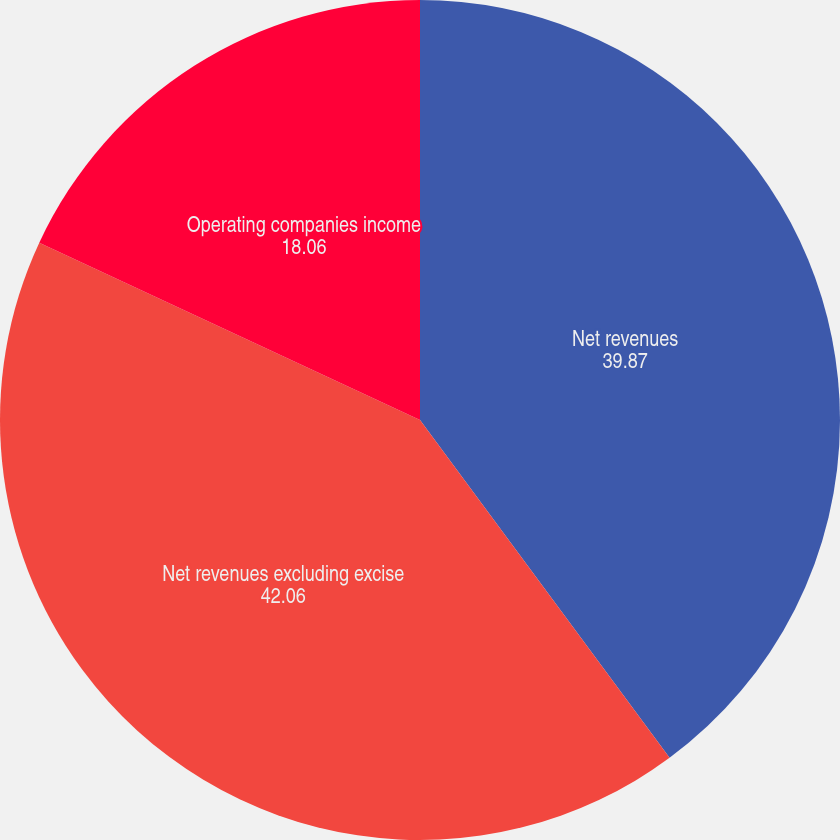<chart> <loc_0><loc_0><loc_500><loc_500><pie_chart><fcel>Net revenues<fcel>Net revenues excluding excise<fcel>Operating companies income<nl><fcel>39.87%<fcel>42.06%<fcel>18.06%<nl></chart> 